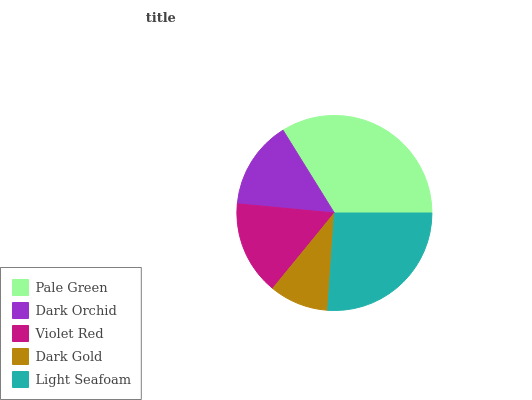Is Dark Gold the minimum?
Answer yes or no. Yes. Is Pale Green the maximum?
Answer yes or no. Yes. Is Dark Orchid the minimum?
Answer yes or no. No. Is Dark Orchid the maximum?
Answer yes or no. No. Is Pale Green greater than Dark Orchid?
Answer yes or no. Yes. Is Dark Orchid less than Pale Green?
Answer yes or no. Yes. Is Dark Orchid greater than Pale Green?
Answer yes or no. No. Is Pale Green less than Dark Orchid?
Answer yes or no. No. Is Violet Red the high median?
Answer yes or no. Yes. Is Violet Red the low median?
Answer yes or no. Yes. Is Dark Orchid the high median?
Answer yes or no. No. Is Dark Orchid the low median?
Answer yes or no. No. 